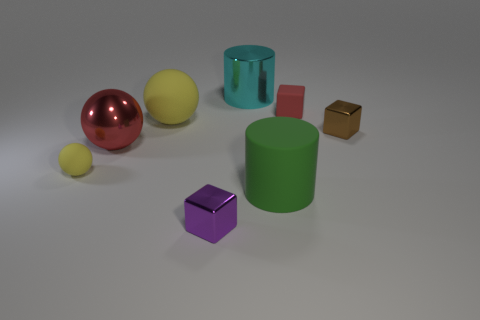There is a large thing that is the same color as the small matte cube; what is it made of?
Your answer should be very brief. Metal. What number of things are either red rubber cubes or matte objects in front of the red cube?
Your answer should be very brief. 4. What material is the brown cube that is the same size as the purple metallic thing?
Provide a short and direct response. Metal. What is the material of the big thing that is on the left side of the tiny purple metallic block and in front of the brown block?
Provide a succinct answer. Metal. Is there a small thing left of the small shiny object that is on the right side of the big cyan shiny cylinder?
Your response must be concise. Yes. How big is the metallic thing that is both on the right side of the purple metallic block and in front of the large metallic cylinder?
Your answer should be compact. Small. What number of yellow objects are either large objects or large cylinders?
Your answer should be very brief. 1. What shape is the yellow matte thing that is the same size as the red rubber block?
Your response must be concise. Sphere. How many other objects are the same color as the big rubber ball?
Provide a succinct answer. 1. What size is the metallic block that is in front of the yellow rubber sphere in front of the big yellow matte ball?
Make the answer very short. Small. 